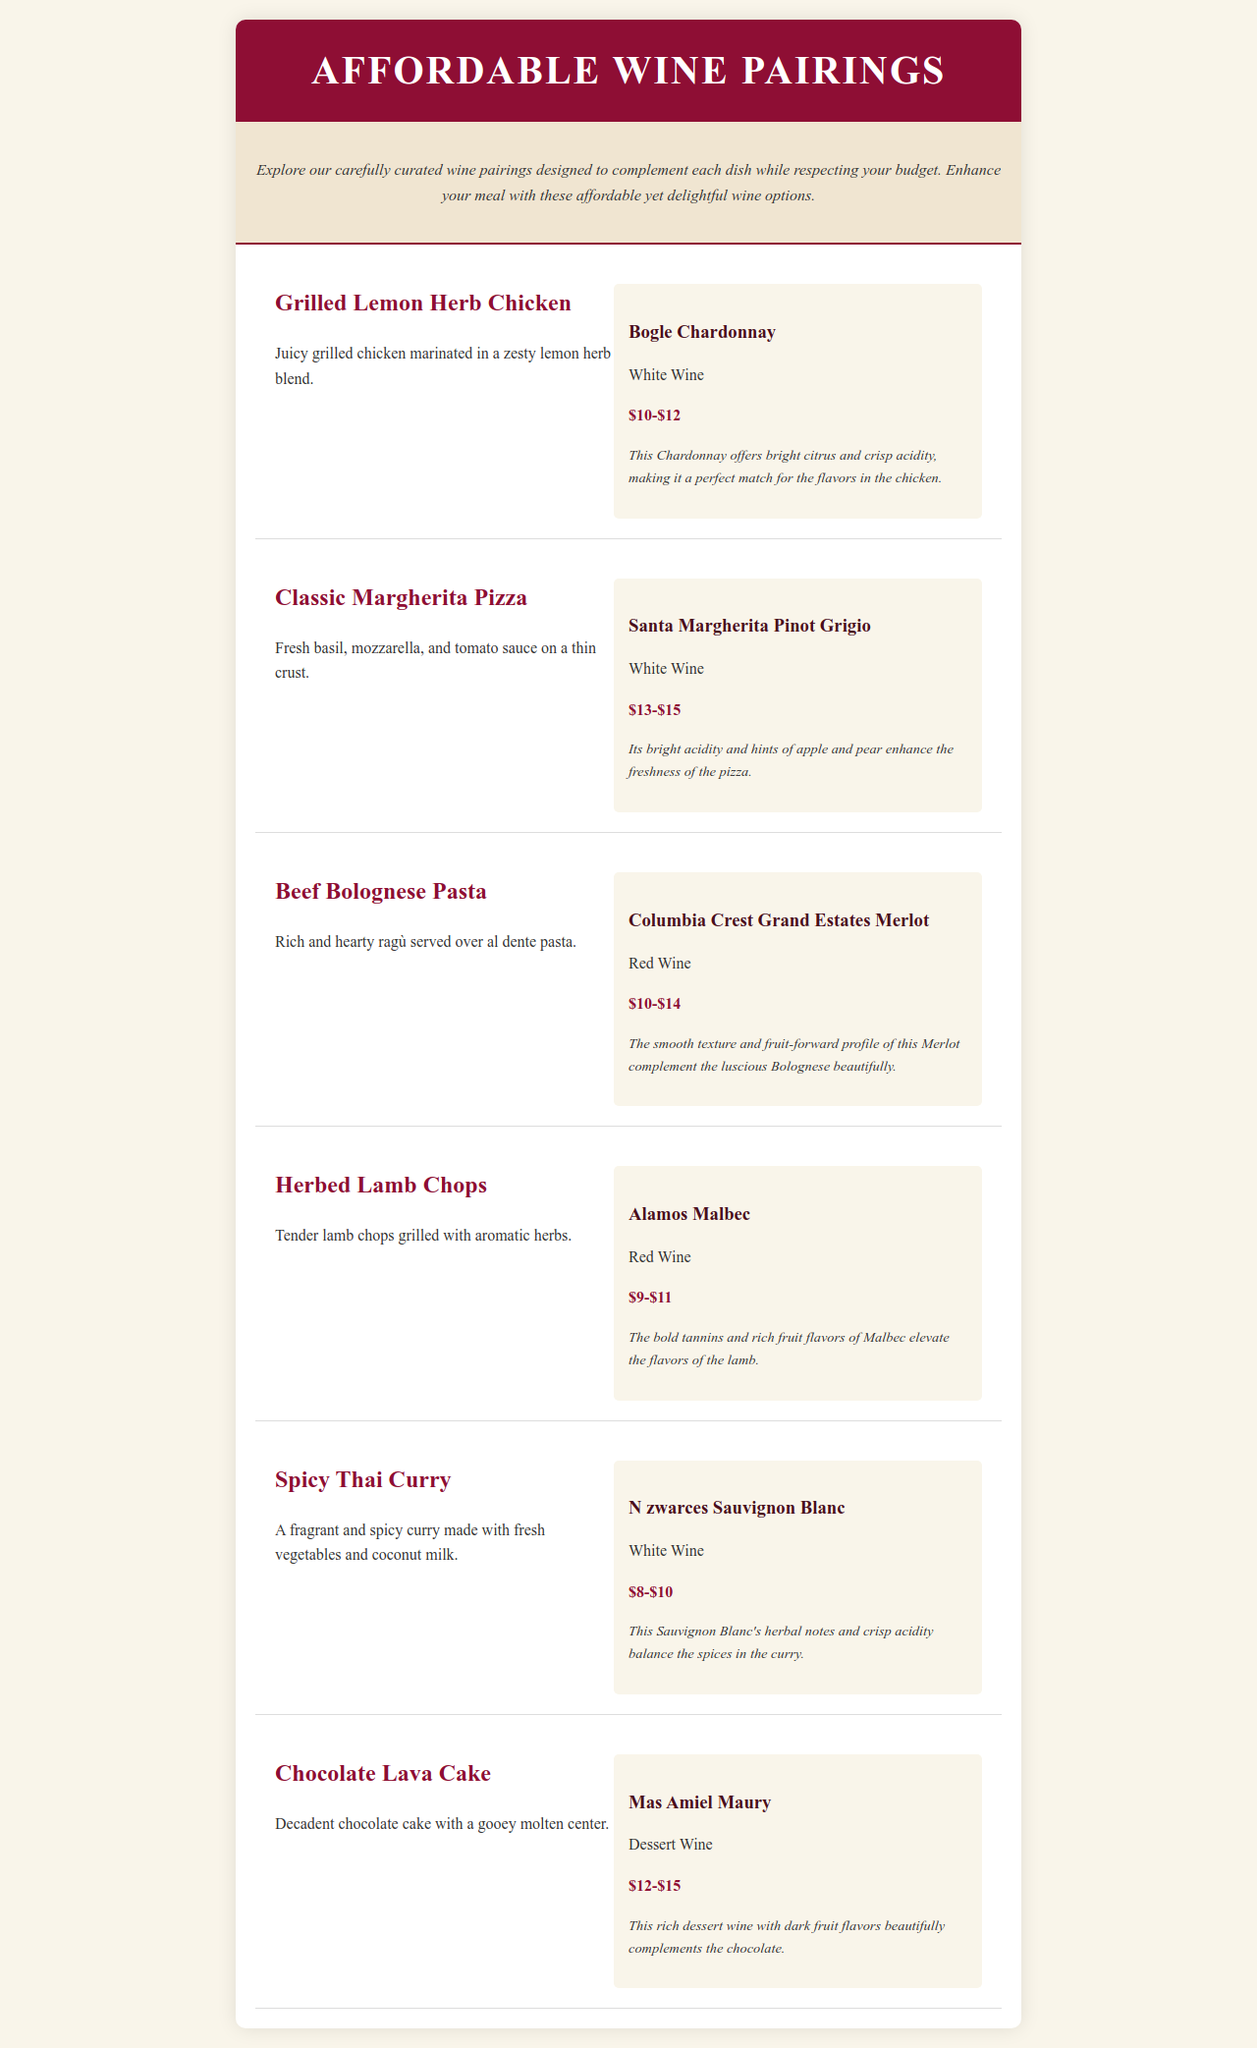What is the first dish listed on the menu? The first dish listed is "Grilled Lemon Herb Chicken."
Answer: Grilled Lemon Herb Chicken What is the price range for Bogle Chardonnay? The price range for Bogle Chardonnay is mentioned under the wine pairing section.
Answer: $10-$12 Which wine pairs with Beef Bolognese Pasta? The wine pairing for Beef Bolognese Pasta can be found in the wine pairing section.
Answer: Columbia Crest Grand Estates Merlot How much does Alamos Malbec cost? The price range for Alamos Malbec is specified in the wine pairing section.
Answer: $9-$11 What flavor notes does N zwarces Sauvignon Blanc provide? The flavor notes are described in the notes section for N zwarces Sauvignon Blanc.
Answer: Herbal notes and crisp acidity Which dessert wine is paired with the Chocolate Lava Cake? The dessert wine pairing for Chocolate Lava Cake is listed in the wine pairing section.
Answer: Mas Amiel Maury What type of wine complements the Spicy Thai Curry? The type of wine is indicated in the wine pairing section for Spicy Thai Curry.
Answer: White Wine What dish is served with Santa Margherita Pinot Grigio? The dish served with Santa Margherita Pinot Grigio is described in the document.
Answer: Classic Margherita Pizza How is the meat in Herbed Lamb Chops described? The description of the meat in Herbed Lamb Chops is provided in the dish info section.
Answer: Tender 